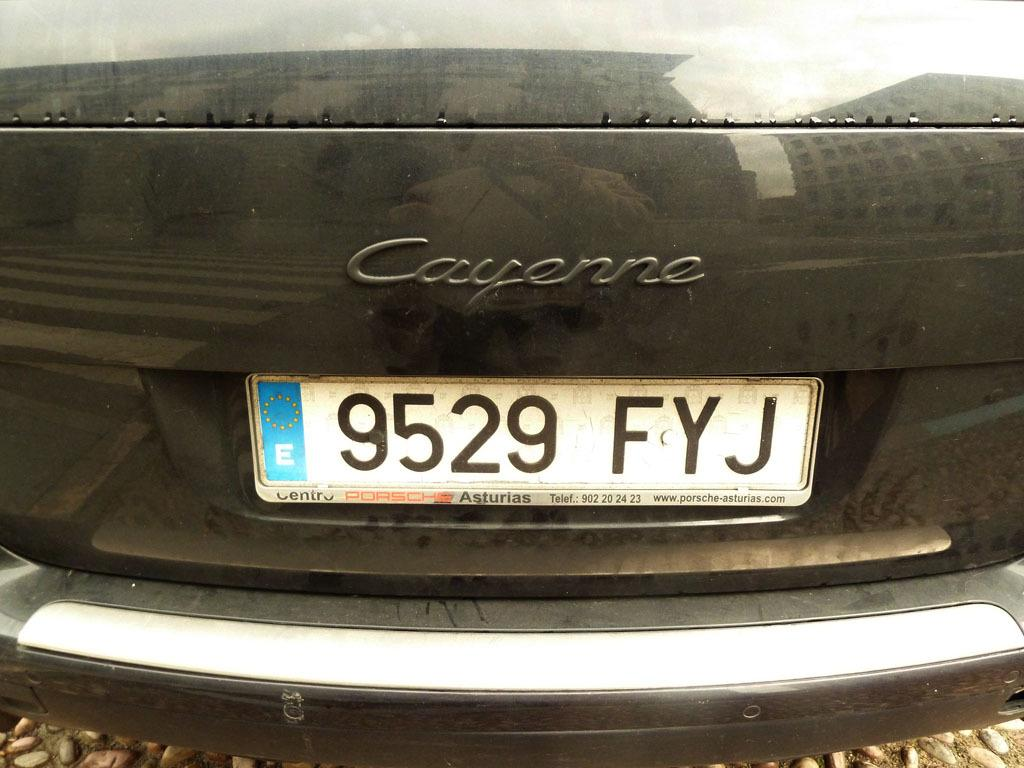<image>
Present a compact description of the photo's key features. A close up of a Cayenne car with the licence plate 9529 FYJ 